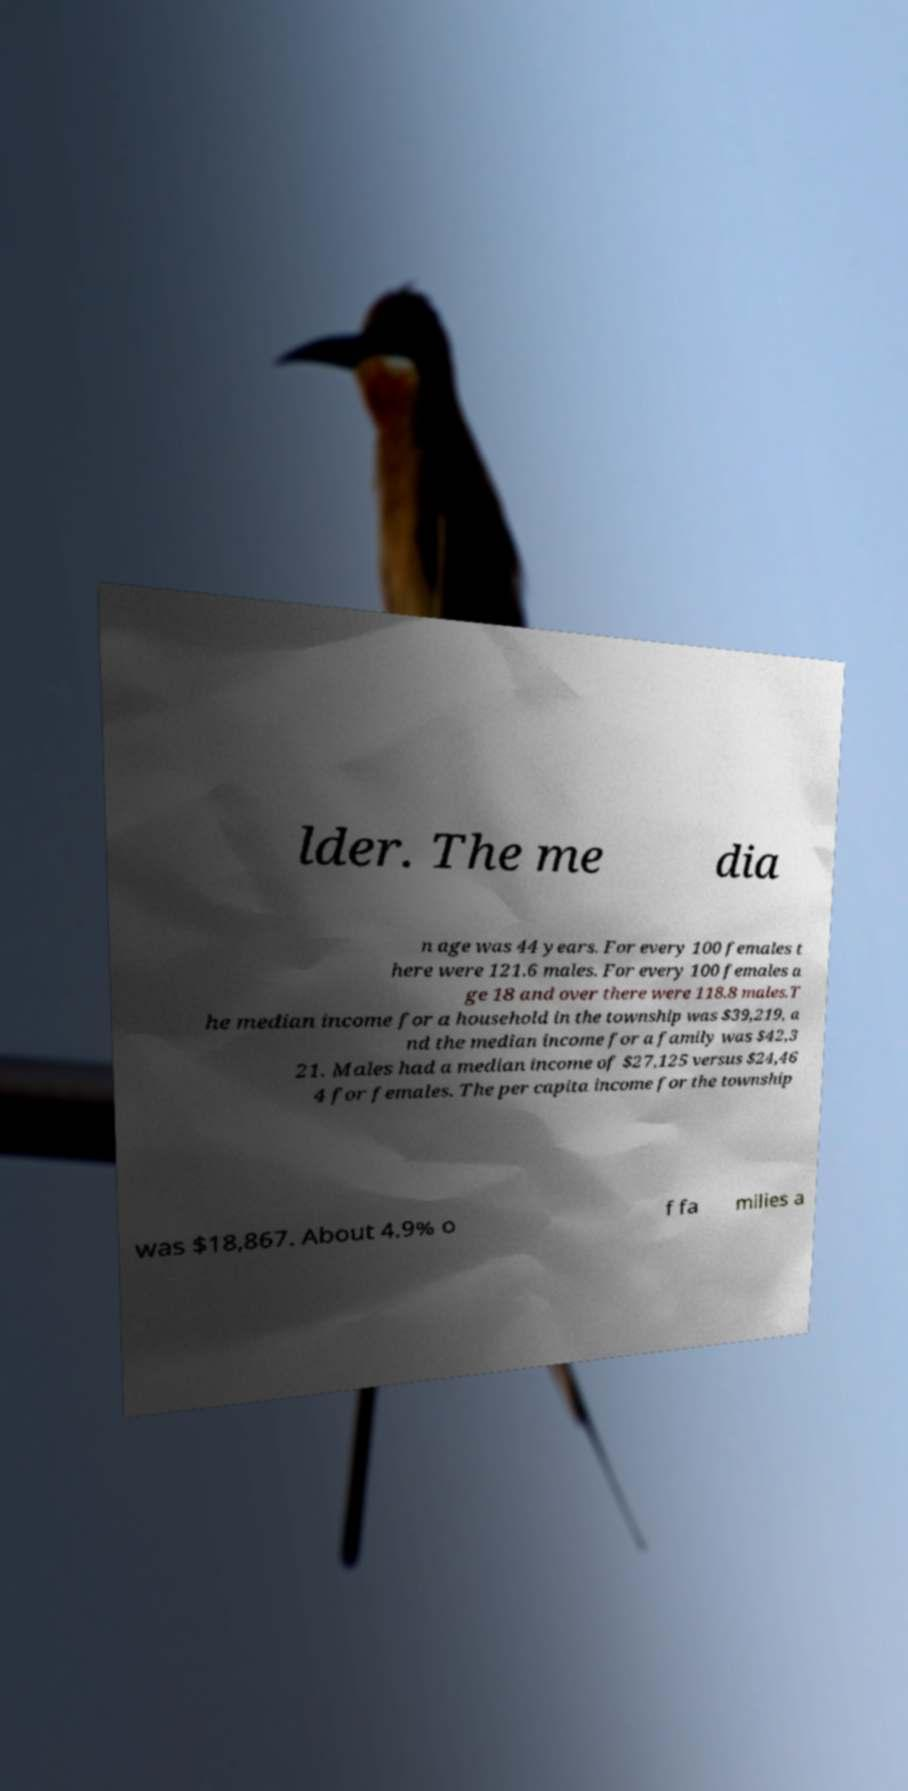Can you read and provide the text displayed in the image?This photo seems to have some interesting text. Can you extract and type it out for me? lder. The me dia n age was 44 years. For every 100 females t here were 121.6 males. For every 100 females a ge 18 and over there were 118.8 males.T he median income for a household in the township was $39,219, a nd the median income for a family was $42,3 21. Males had a median income of $27,125 versus $24,46 4 for females. The per capita income for the township was $18,867. About 4.9% o f fa milies a 